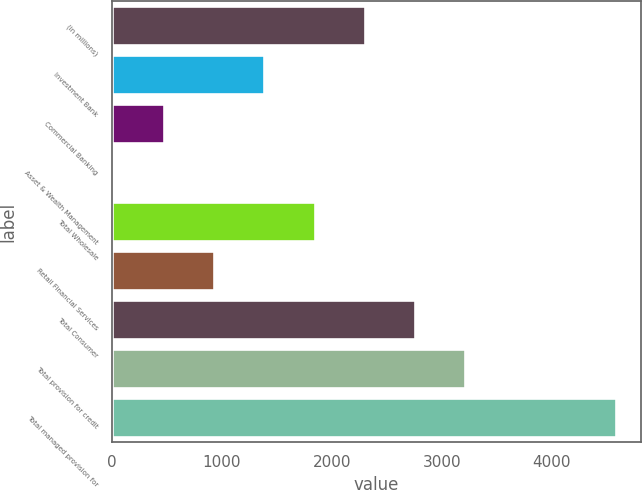Convert chart. <chart><loc_0><loc_0><loc_500><loc_500><bar_chart><fcel>(in millions)<fcel>Investment Bank<fcel>Commercial Banking<fcel>Asset & Wealth Management<fcel>Total Wholesale<fcel>Retail Financial Services<fcel>Total Consumer<fcel>Total provision for credit<fcel>Total managed provision for<nl><fcel>2299<fcel>1385<fcel>471<fcel>14<fcel>1842<fcel>928<fcel>2756<fcel>3213<fcel>4584<nl></chart> 